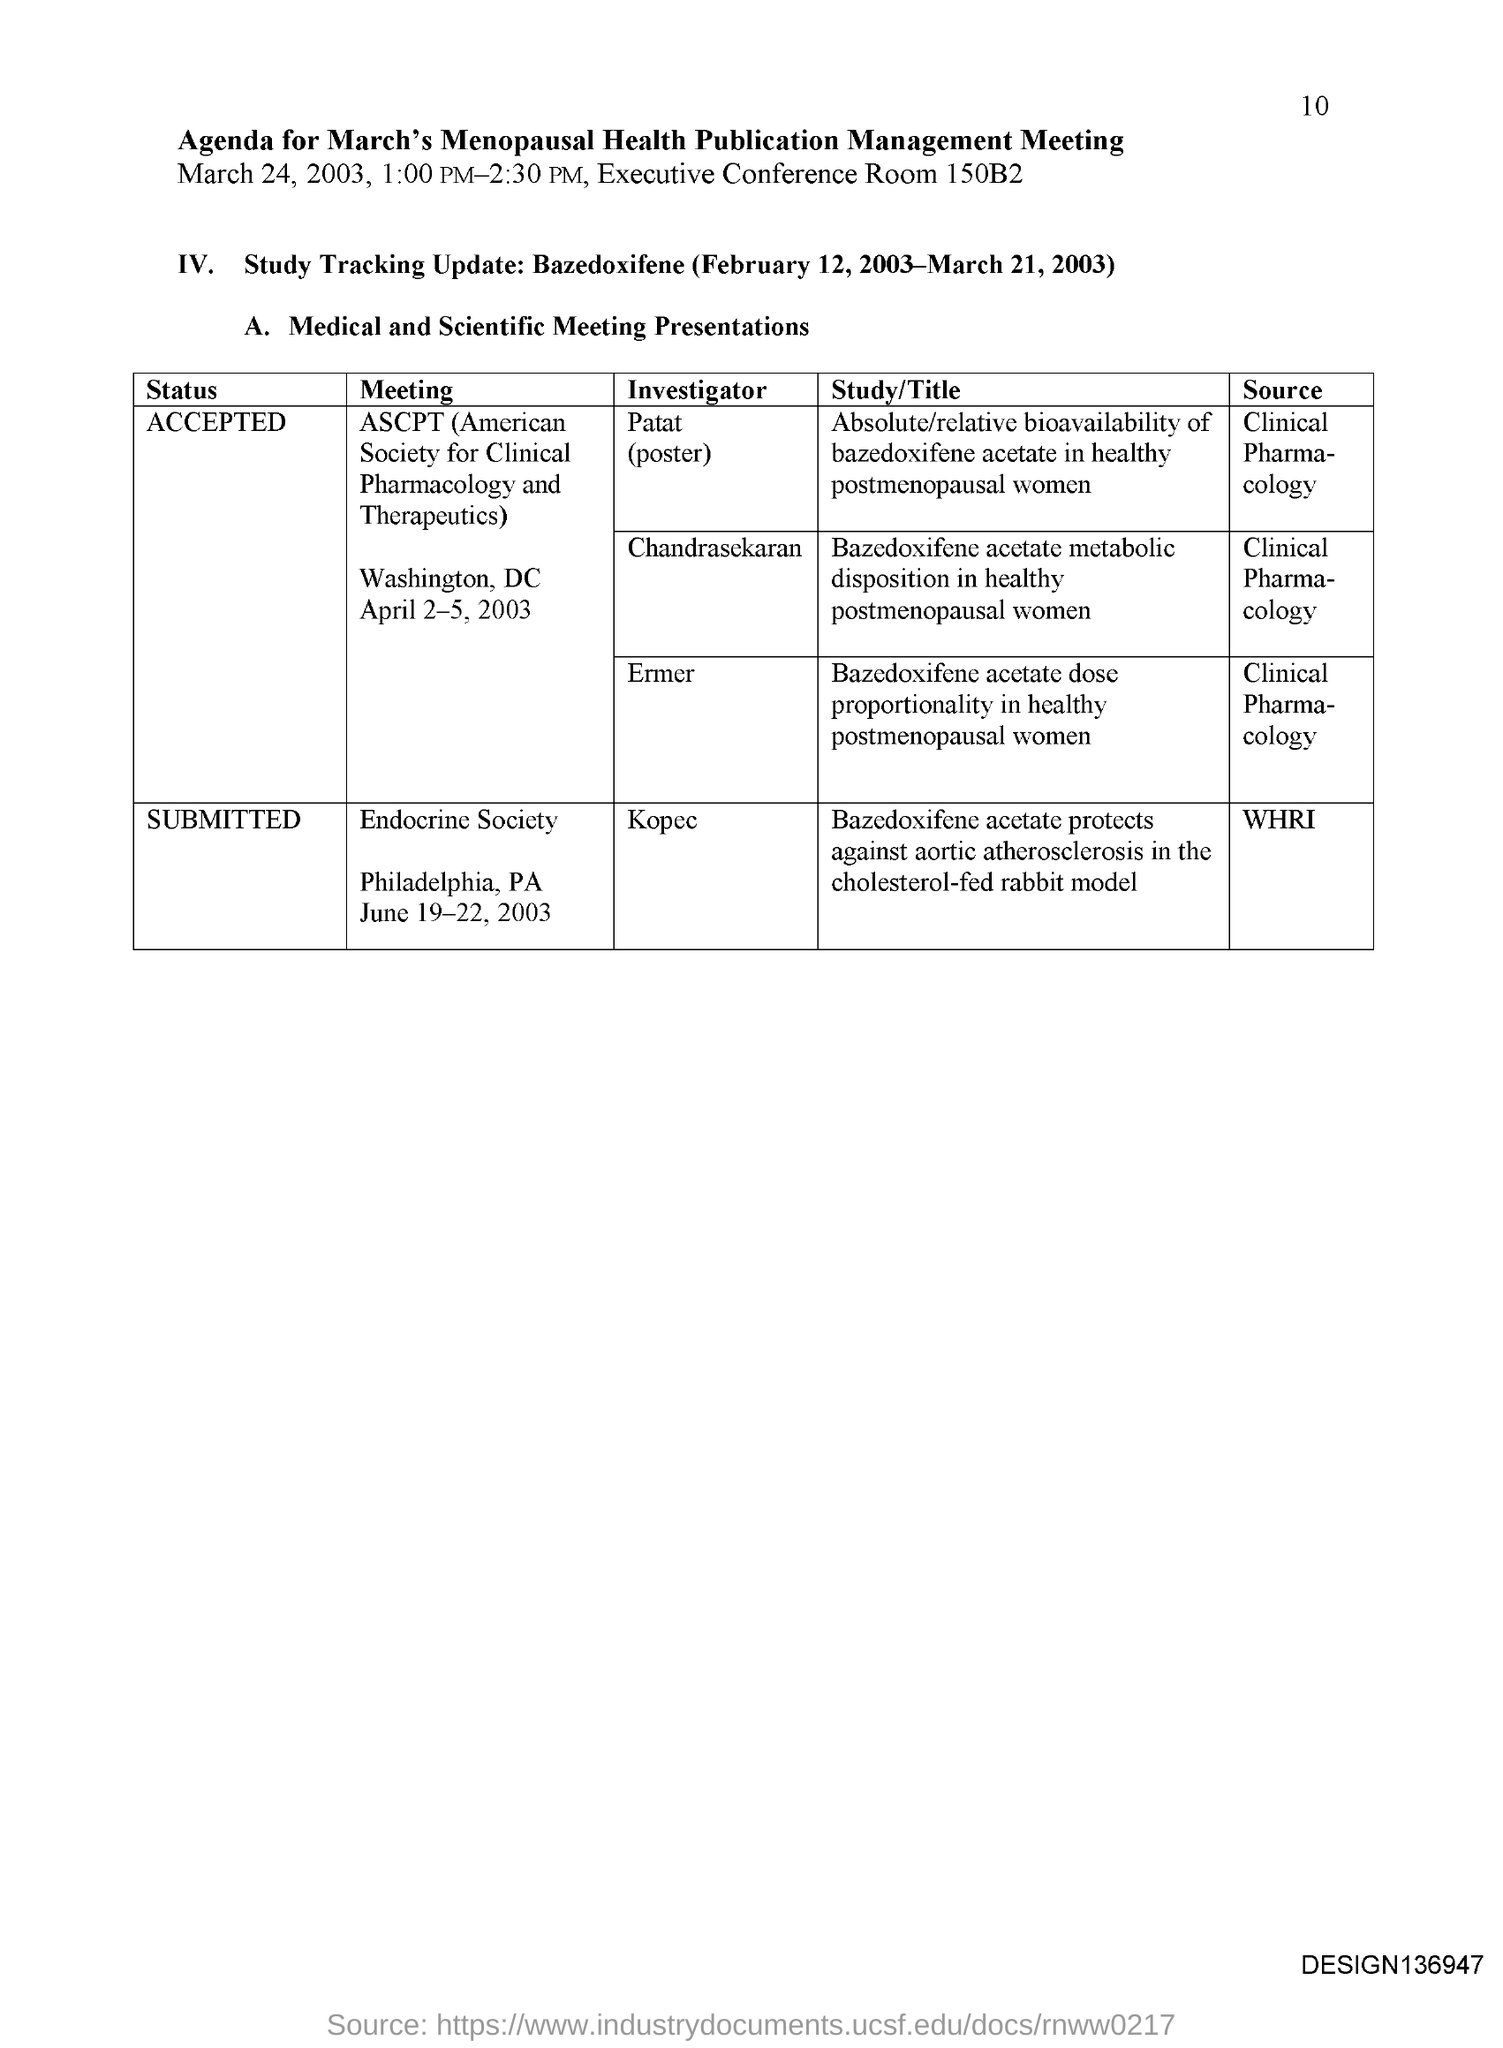Who is the investigator of the meeting Endocrine society?
Make the answer very short. Kopec. 